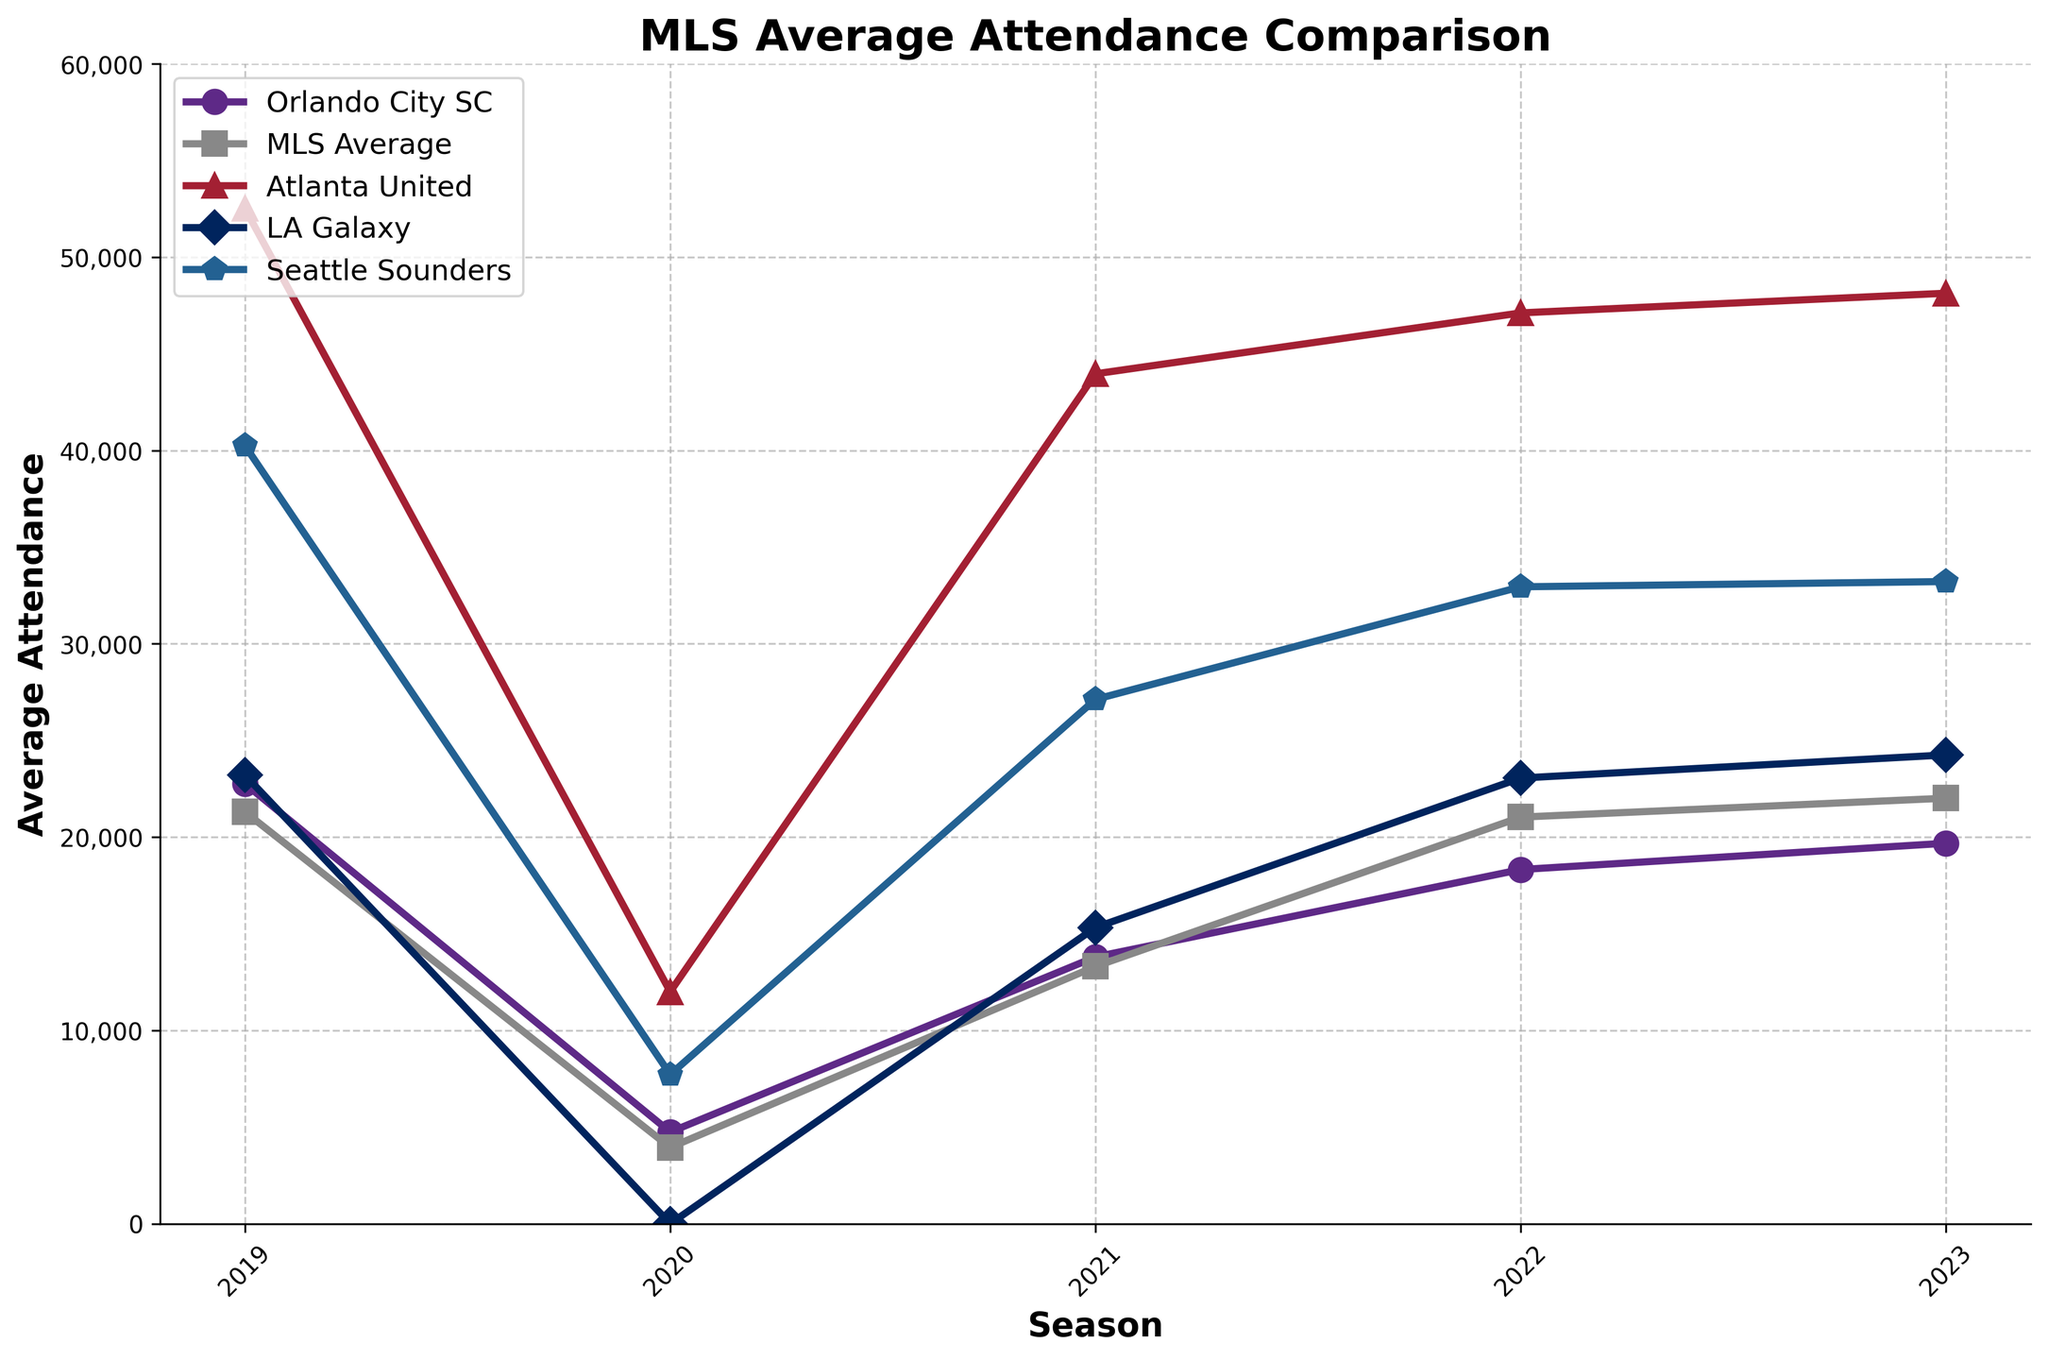What season had the lowest average attendance for Orlando City SC? The plot shows data for each season, and the lowest point on the Orlando City SC line is in 2020.
Answer: 2020 How does the average attendance of Orlando City SC in 2020 compare to that of LA Galaxy? In 2020, Orlando City SC had an average attendance of 4742, while LA Galaxy had 0.
Answer: LA Galaxy had 0, Orlando City SC had 4742 Which season showed the highest average attendance for the MLS Average? By comparing the heights of the MLS Average line across seasons, 2023 has the highest point at 22012.
Answer: 2023 Compare the average attendance of Atlanta United and Seattle Sounders in 2019. Which team had a higher attendance? In 2019, Atlanta United had an attendance of 52510 and Seattle Sounders had 40247, making Atlanta United's attendance higher.
Answer: Atlanta United What is the trend for Orlando City SC's attendance from 2020 to 2023? The plot shows a steady increase in attendance for Orlando City SC from 4742 in 2020 to 19682 in 2023.
Answer: Increasing Which team had the most significant drop in average attendance from 2019 to 2020? Comparing the drops between 2019 and 2020 for all teams, LA Galaxy went from 23205 to 0, which is the most significant drop.
Answer: LA Galaxy When did Orlando City SC's average attendance first exceed the MLS Average? Around the 2021 season, Orlando City SC's average attendance of 13802 exceeded the MLS Average of 13310.
Answer: 2021 Compare the 2021 average attendance of Orlando City SC to that of Atlanta United. In 2021, Orlando City SC had 13802, while Atlanta United had 43964.
Answer: Orlando City SC: 13802, Atlanta United: 43964 How did the average attendance for Seattle Sounders change from 2021 to 2022? Seattle Sounders' attendance went from 27124 in 2021 to 32947 in 2022, indicating an increase.
Answer: Increased What is the median average attendance for Orlando City SC over the past five seasons? The attendance figures from 2019 to 2023 are 22761, 4742, 13802, 18321, 19682. Sorting these, we get 4742, 13802, 18321, 19682, 22761. The median is 18321.
Answer: 18321 